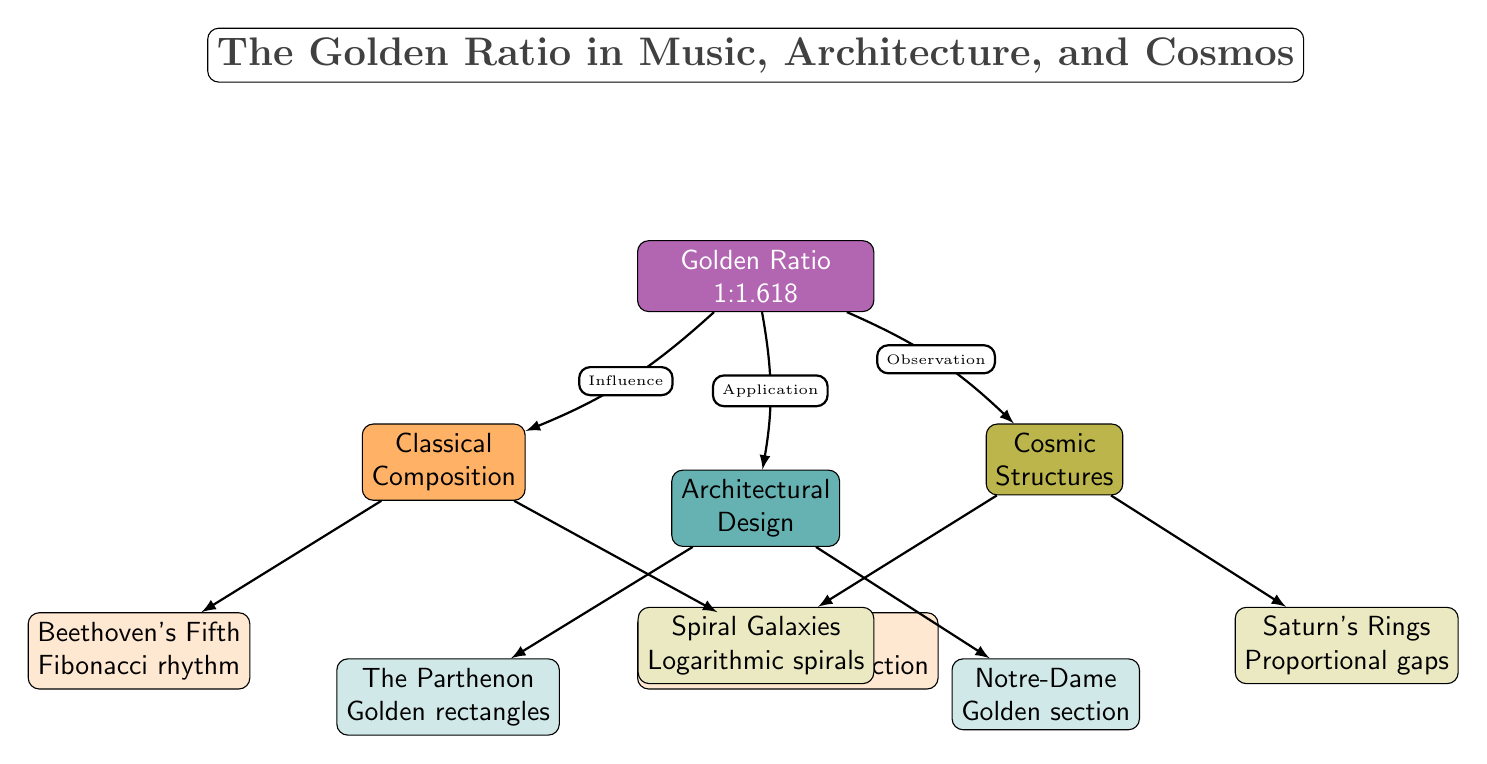What is the main concept of the diagram? The main concept, indicated in the central node, is the "Golden Ratio 1:1.618," which is the foundational idea that connects all other nodes in the diagram.
Answer: Golden Ratio 1:1.618 How many main categories are represented in the diagram? The diagram has three main categories: Classical Composition, Architectural Design, and Cosmic Structures. This can be seen as three nodes branching out from the central concept.
Answer: 3 Which classical composer is linked to Fibonacci rhythm? The node under "Classical Composition" indicates that Beethoven is associated with Fibonacci rhythm, connecting the idea of mathematics in music to his work.
Answer: Beethoven What architectural structure is associated with golden rectangles? Under the "Architectural Design" category, the Parthenon node represents the architectural structure linked to golden rectangles, highlighting the application of the golden ratio in historical architecture.
Answer: The Parthenon What cosmic structure is observed through proportional gaps? The diagram shows that Saturn's Rings are the cosmic structure which displays the concept of proportional gaps, indicating a mathematical relationship in nature.
Answer: Saturn's Rings Which of the three main categories contains two sub-nodes? The "Classical Composition" category has two sub-nodes: one for Beethoven and one for Bach, making it the only category represented with two distinct examples.
Answer: Classical Composition What kind of spiral is associated with spiral galaxies? The "Spiral Galaxies" node is connected to Logarithmic spirals, as indicated in the diagram, showcasing the nature of these cosmic structures.
Answer: Logarithmic spirals How is the influence of the golden ratio described in music? The influence described in the diagram indicates that it relates to Classical Composition, specifically in works like Beethoven's and Bach's, emphasizing mathematical principles in musical composition.
Answer: Influence Which architectural structure is associated with the golden section? In the "Architectural Design" category, Notre-Dame highlights its association with the golden section, indicating another application of the golden ratio in architecture.
Answer: Notre-Dame 